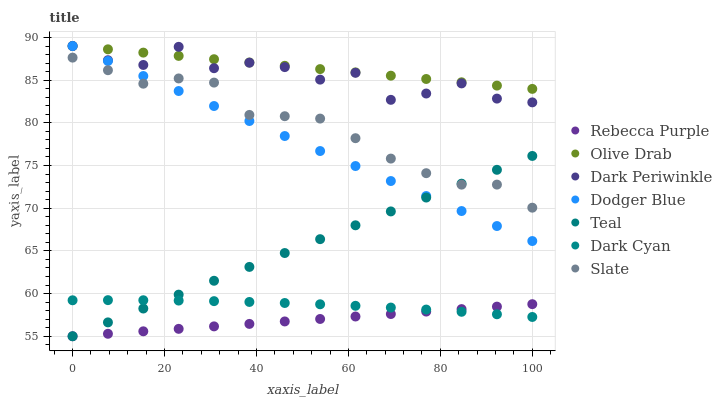Does Rebecca Purple have the minimum area under the curve?
Answer yes or no. Yes. Does Olive Drab have the maximum area under the curve?
Answer yes or no. Yes. Does Dodger Blue have the minimum area under the curve?
Answer yes or no. No. Does Dodger Blue have the maximum area under the curve?
Answer yes or no. No. Is Dodger Blue the smoothest?
Answer yes or no. Yes. Is Dark Periwinkle the roughest?
Answer yes or no. Yes. Is Rebecca Purple the smoothest?
Answer yes or no. No. Is Rebecca Purple the roughest?
Answer yes or no. No. Does Rebecca Purple have the lowest value?
Answer yes or no. Yes. Does Dodger Blue have the lowest value?
Answer yes or no. No. Does Olive Drab have the highest value?
Answer yes or no. Yes. Does Rebecca Purple have the highest value?
Answer yes or no. No. Is Dark Cyan less than Dark Periwinkle?
Answer yes or no. Yes. Is Dark Periwinkle greater than Teal?
Answer yes or no. Yes. Does Dark Periwinkle intersect Dodger Blue?
Answer yes or no. Yes. Is Dark Periwinkle less than Dodger Blue?
Answer yes or no. No. Is Dark Periwinkle greater than Dodger Blue?
Answer yes or no. No. Does Dark Cyan intersect Dark Periwinkle?
Answer yes or no. No. 